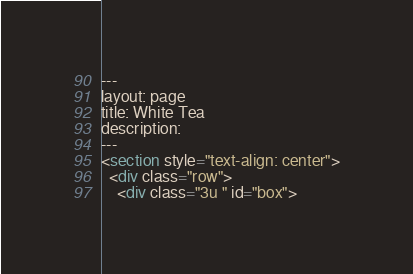Convert code to text. <code><loc_0><loc_0><loc_500><loc_500><_HTML_>---
layout: page
title: White Tea
description:
---
<section style="text-align: center">
  <div class="row">
    <div class="3u " id="box"></code> 